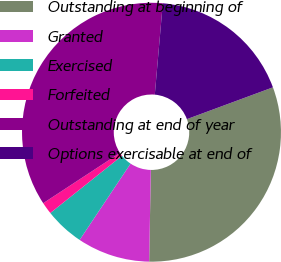Convert chart. <chart><loc_0><loc_0><loc_500><loc_500><pie_chart><fcel>Outstanding at beginning of<fcel>Granted<fcel>Exercised<fcel>Forfeited<fcel>Outstanding at end of year<fcel>Options exercisable at end of<nl><fcel>30.92%<fcel>9.08%<fcel>4.91%<fcel>1.49%<fcel>35.62%<fcel>17.97%<nl></chart> 